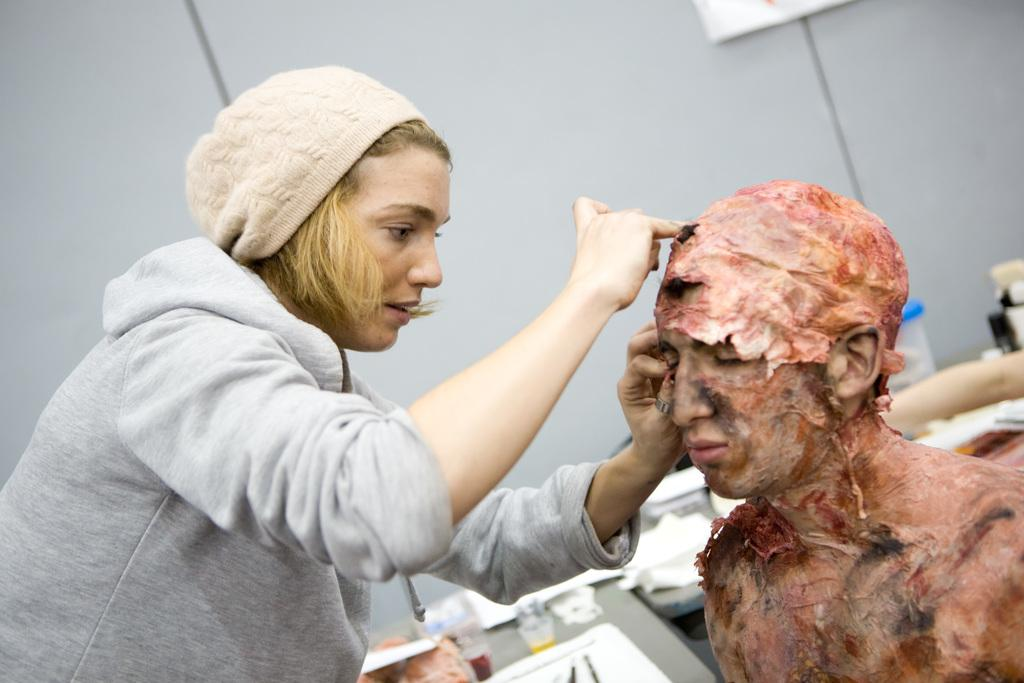What is the woman on the left side of the image doing? The woman is doing makeup to a person. What is the person who is receiving makeup doing? The person is sitting. What can be seen in the background of the image? There are glasses, documents, a wall, and other objects in the background of the image. What type of song is being sung by the person in the image? There is no indication in the image that a song is being sung, as the woman is doing makeup and the person is sitting. Can you tell me where the sidewalk is located in the image? There is no sidewalk present in the image. 